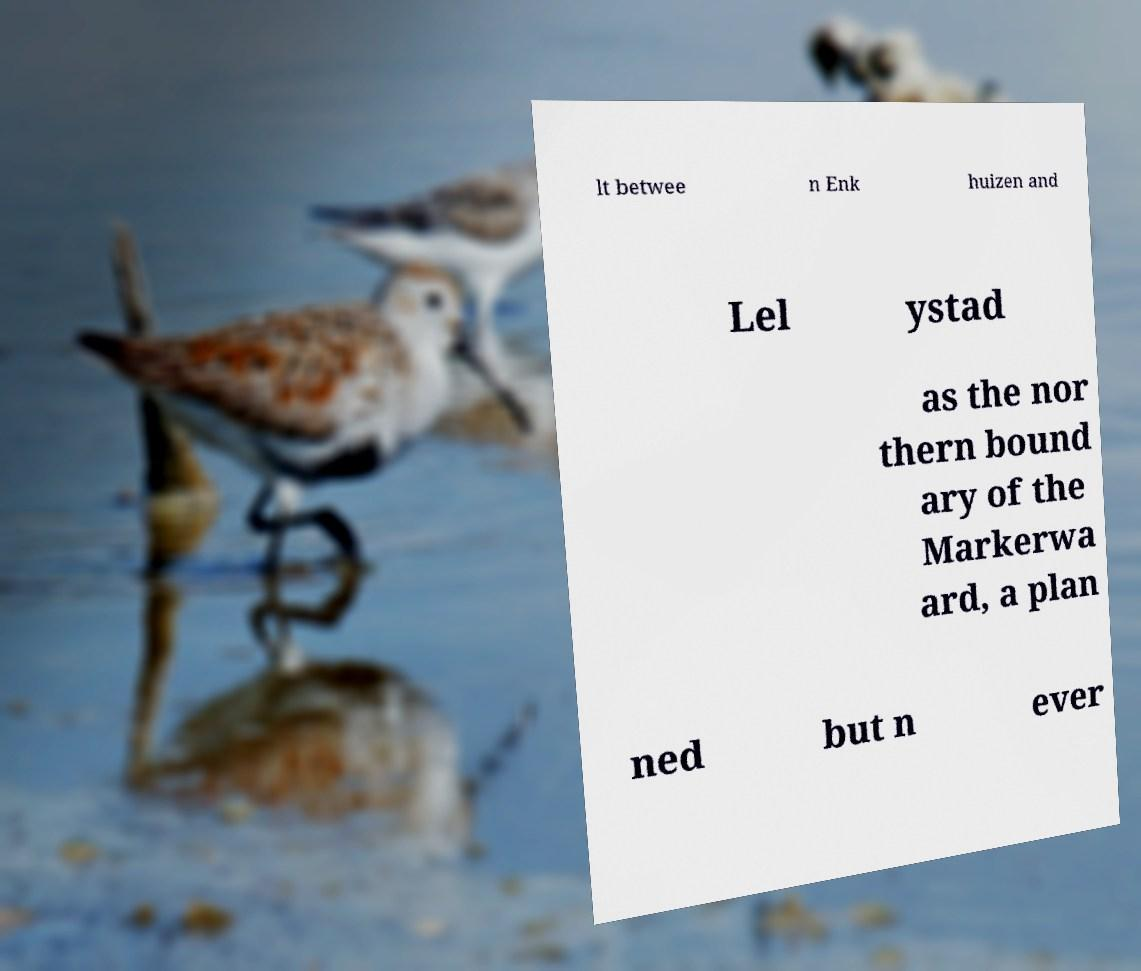Could you extract and type out the text from this image? lt betwee n Enk huizen and Lel ystad as the nor thern bound ary of the Markerwa ard, a plan ned but n ever 